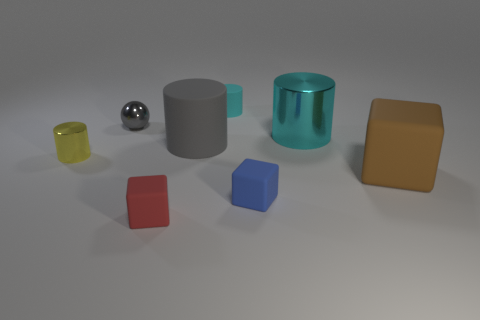Which objects in the picture appear to have a reflective surface? The objects with reflective surfaces include the small silver sphere and the large cyan-colored cylinder on the right. These objects have a shiny appearance that reflects the environment, indicating a smooth and potentially metallic or plastic composition. 